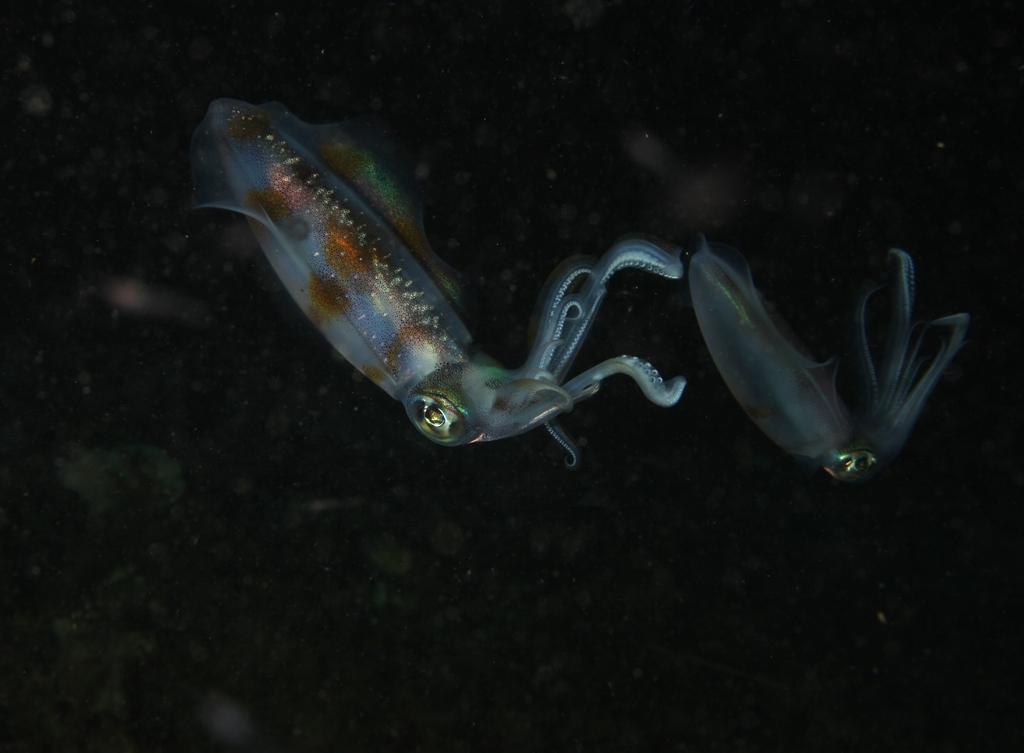Could you give a brief overview of what you see in this image? The picture consists of squids in a water body. 